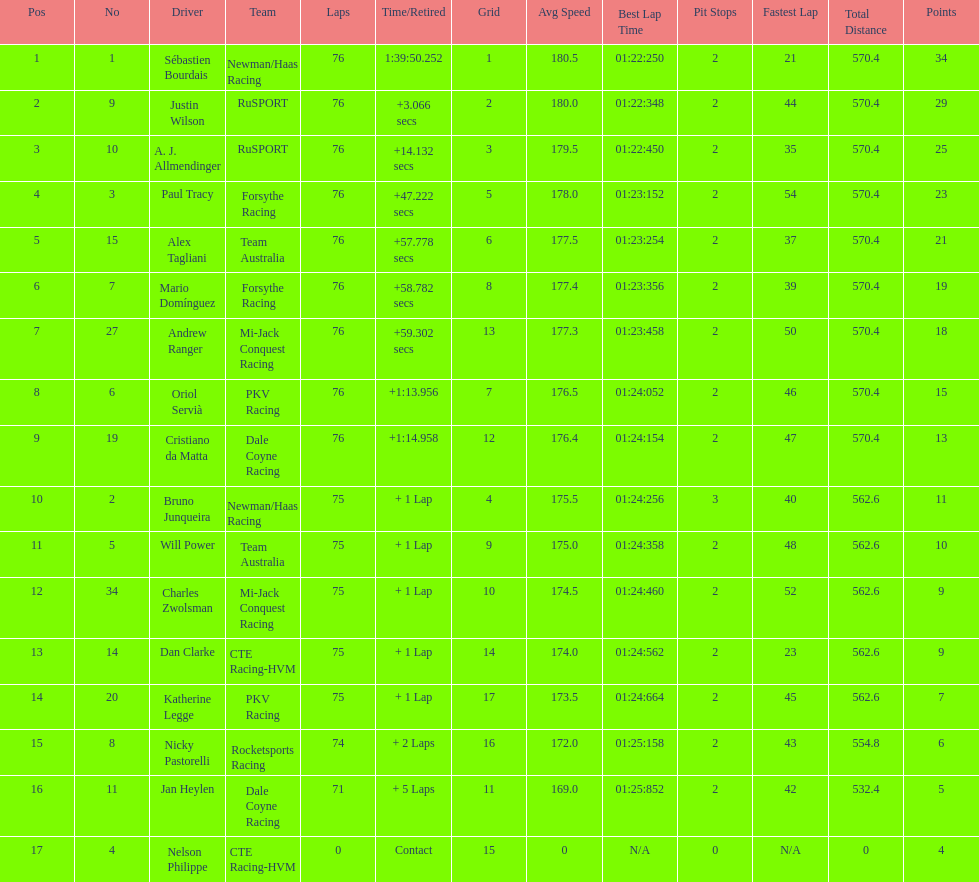What is the total point difference between the driver who received the most points and the driver who received the least? 30. 